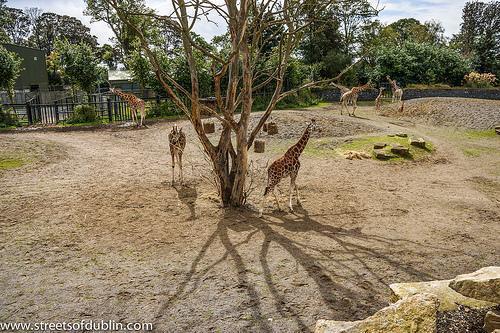How many trees inside the fence?
Give a very brief answer. 1. How many giraffes inside the fence?
Give a very brief answer. 8. 